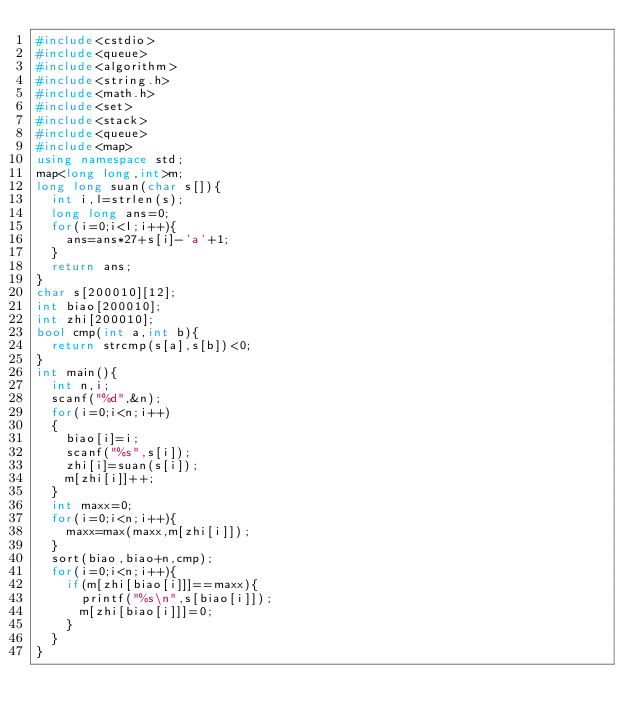Convert code to text. <code><loc_0><loc_0><loc_500><loc_500><_C++_>#include<cstdio>
#include<queue>
#include<algorithm>
#include<string.h>
#include<math.h>
#include<set>
#include<stack>
#include<queue>
#include<map>
using namespace std;
map<long long,int>m;
long long suan(char s[]){
	int i,l=strlen(s);
	long long ans=0;
	for(i=0;i<l;i++){
		ans=ans*27+s[i]-'a'+1;
	}
	return ans;
}
char s[200010][12];
int biao[200010];
int zhi[200010];
bool cmp(int a,int b){
	return strcmp(s[a],s[b])<0;
}
int main(){
	int n,i;
	scanf("%d",&n);
	for(i=0;i<n;i++)
	{
		biao[i]=i;
		scanf("%s",s[i]);
		zhi[i]=suan(s[i]);
		m[zhi[i]]++;
	}
	int maxx=0;
	for(i=0;i<n;i++){
		maxx=max(maxx,m[zhi[i]]);
	}
	sort(biao,biao+n,cmp);
	for(i=0;i<n;i++){
		if(m[zhi[biao[i]]]==maxx){
			printf("%s\n",s[biao[i]]);
			m[zhi[biao[i]]]=0;
		}
	}
}</code> 